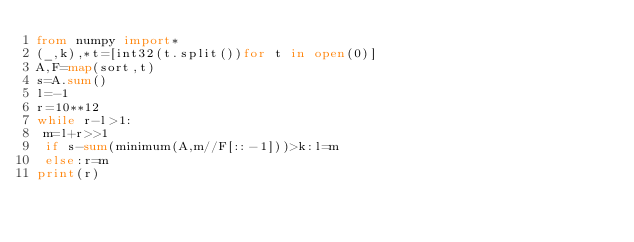<code> <loc_0><loc_0><loc_500><loc_500><_Python_>from numpy import*
(_,k),*t=[int32(t.split())for t in open(0)]
A,F=map(sort,t)
s=A.sum()
l=-1
r=10**12
while r-l>1:
 m=l+r>>1
 if s-sum(minimum(A,m//F[::-1]))>k:l=m
 else:r=m
print(r)</code> 